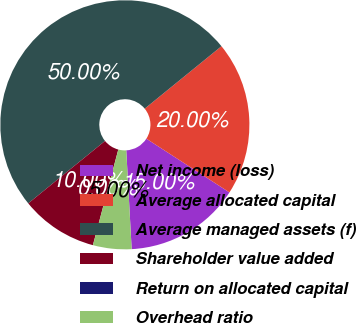Convert chart to OTSL. <chart><loc_0><loc_0><loc_500><loc_500><pie_chart><fcel>Net income (loss)<fcel>Average allocated capital<fcel>Average managed assets (f)<fcel>Shareholder value added<fcel>Return on allocated capital<fcel>Overhead ratio<nl><fcel>15.0%<fcel>20.0%<fcel>50.0%<fcel>10.0%<fcel>0.0%<fcel>5.0%<nl></chart> 